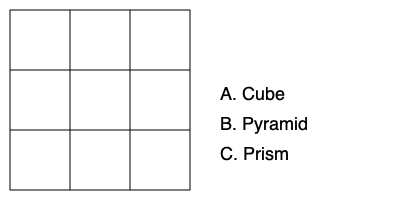As a developmental psychologist studying spatial reasoning in children, you encounter a task where participants must identify the 3D shape that would result from folding the given 2D net. Which shape would be formed by folding this net? To determine the 3D shape that would result from folding this 2D net, we need to analyze its structure:

1. The net consists of a $3 \times 3$ grid of squares.

2. In a cube, each face is connected to four other faces (excluding the opposite face).

3. Examining the net:
   - The center square is surrounded by four squares, which could form the sides of a cube.
   - The corner squares can fold up to form the top and bottom faces of the cube.

4. Mentally folding the net:
   - The four squares adjacent to the center square fold up to form four vertical faces.
   - The corner squares fold to form the top and bottom faces.

5. This configuration results in six square faces connected at right angles, which is the definition of a cube.

6. Neither a pyramid nor a prism would require a $3 \times 3$ square grid net.

Therefore, the 3D shape that would be formed by folding this net is a cube.
Answer: Cube 